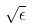<formula> <loc_0><loc_0><loc_500><loc_500>\sqrt { \epsilon }</formula> 